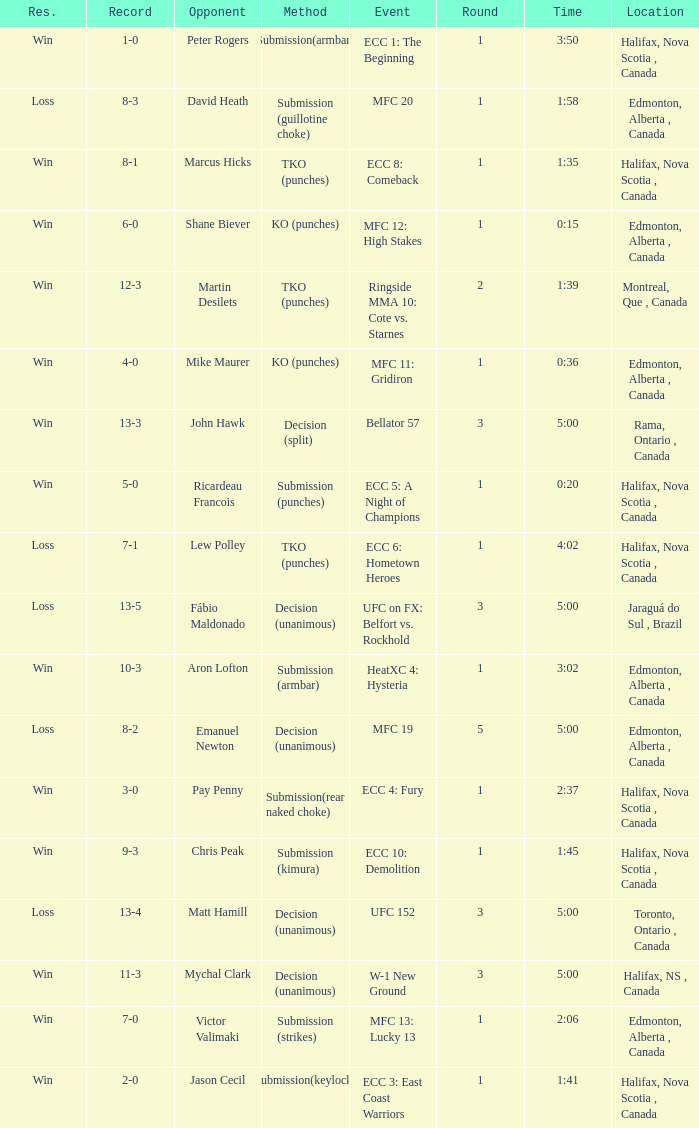What is the round of the match with Emanuel Newton as the opponent? 5.0. 